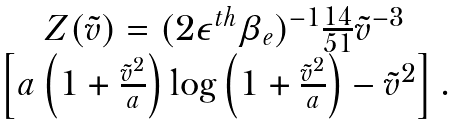<formula> <loc_0><loc_0><loc_500><loc_500>\begin{array} { c } Z ( \tilde { v } ) = ( 2 \epsilon ^ { t h } \beta _ { e } ) ^ { - 1 } \frac { 1 4 } { 5 1 } \tilde { v } ^ { - 3 } \\ \left [ a \left ( 1 + \frac { \tilde { v } ^ { 2 } } { a } \right ) \log \left ( 1 + \frac { \tilde { v } ^ { 2 } } { a } \right ) - \tilde { v } ^ { 2 } \right ] . \end{array}</formula> 